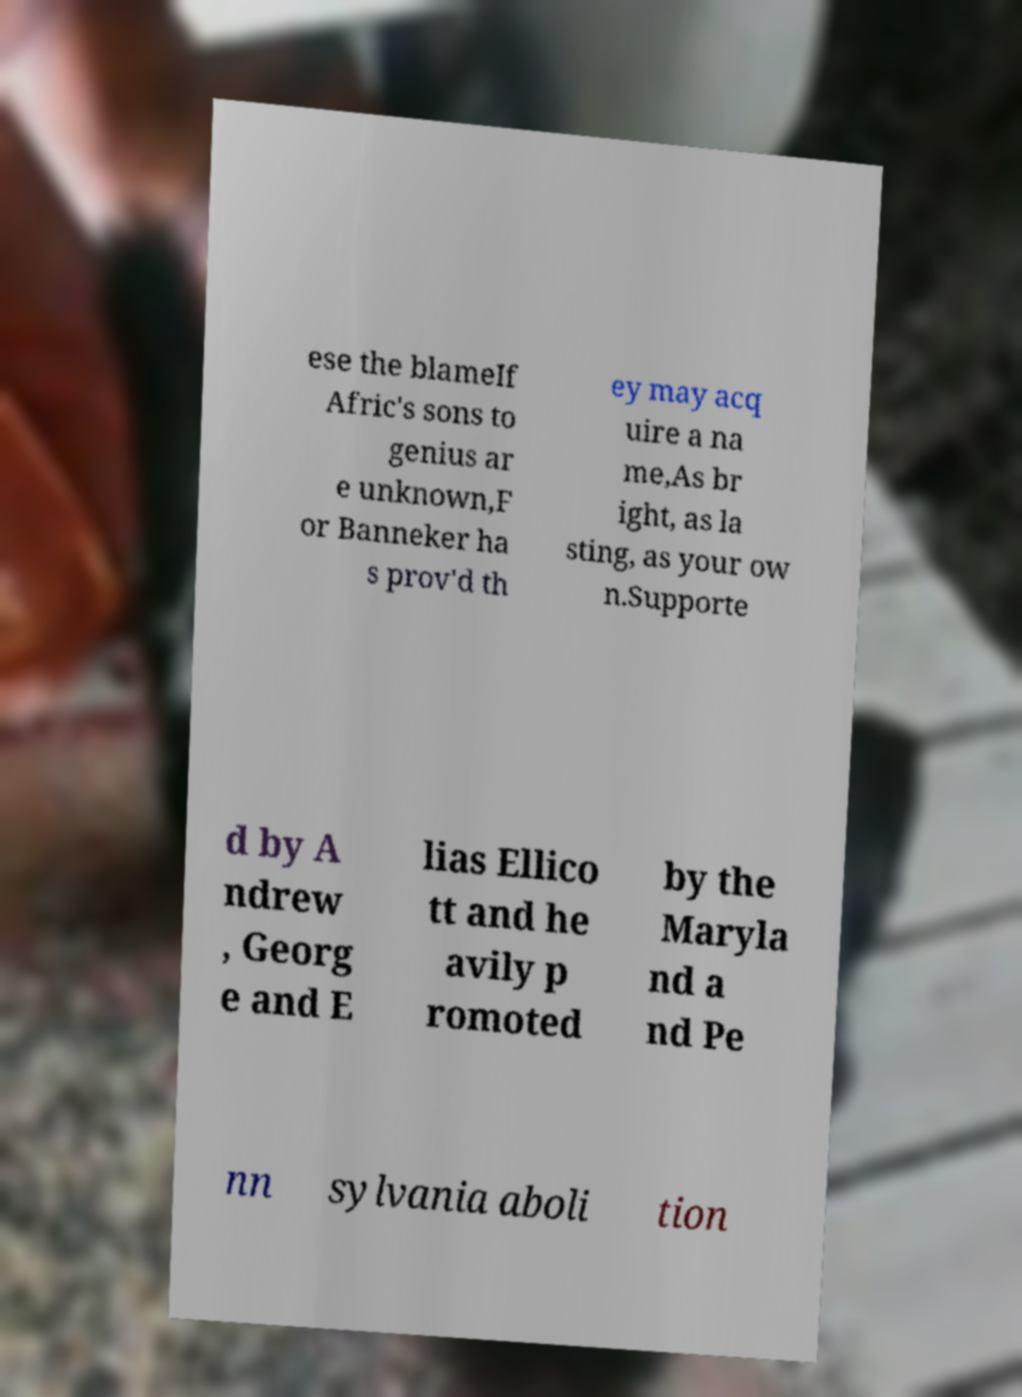Please identify and transcribe the text found in this image. ese the blameIf Afric's sons to genius ar e unknown,F or Banneker ha s prov'd th ey may acq uire a na me,As br ight, as la sting, as your ow n.Supporte d by A ndrew , Georg e and E lias Ellico tt and he avily p romoted by the Maryla nd a nd Pe nn sylvania aboli tion 